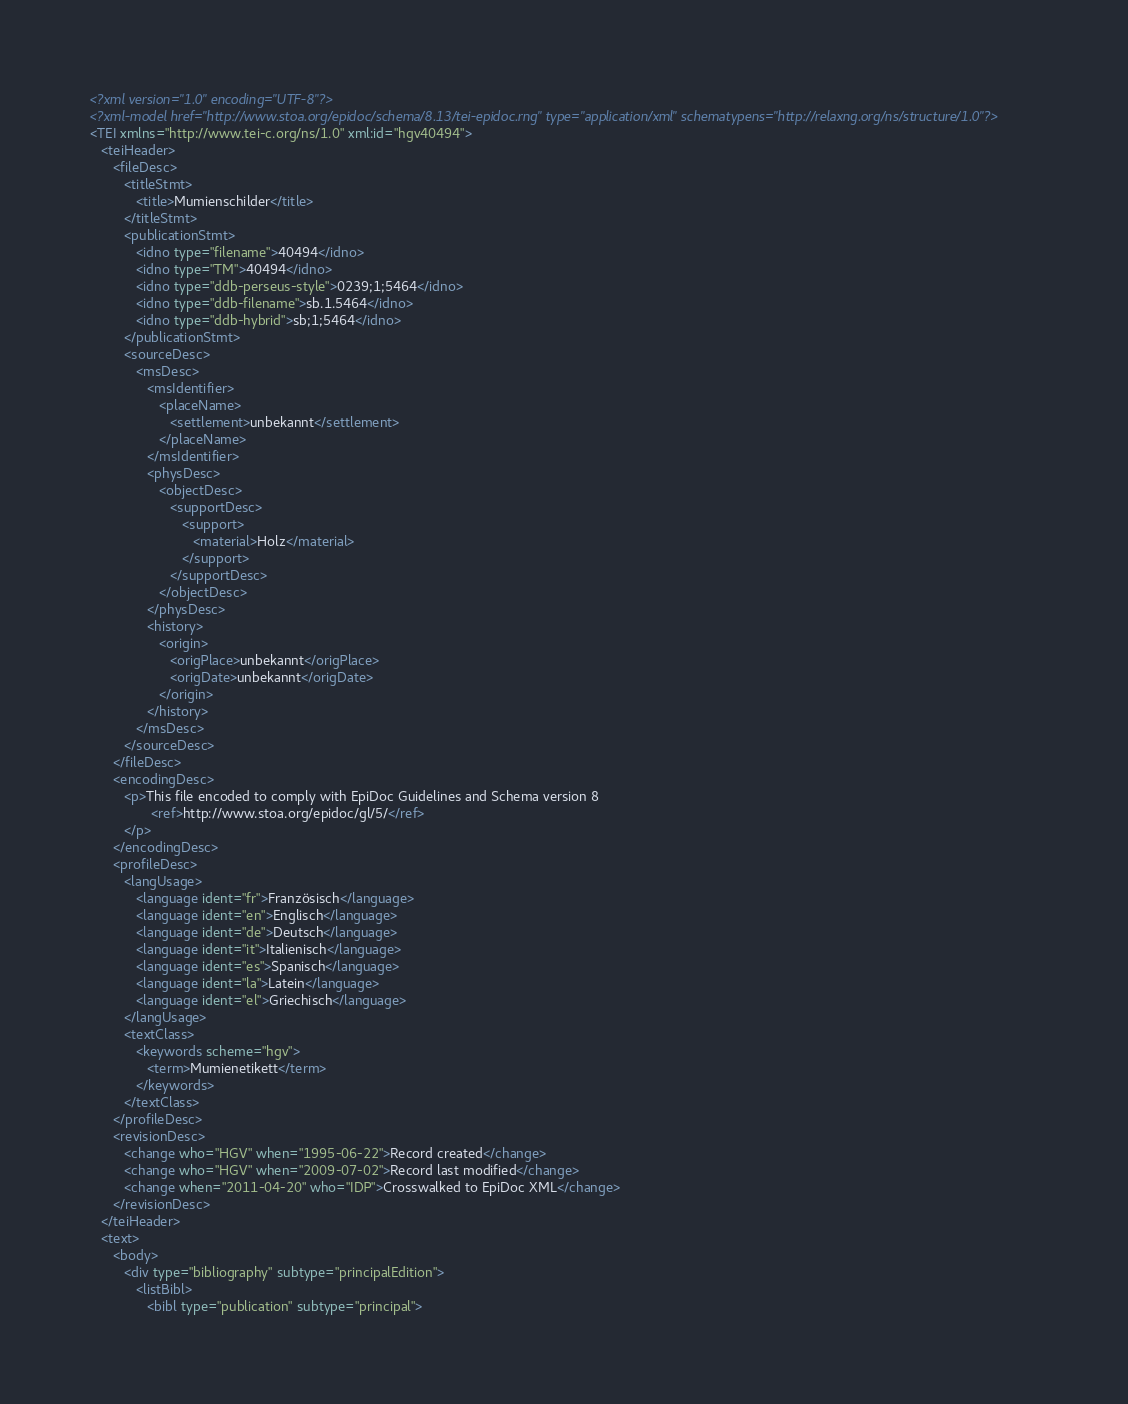<code> <loc_0><loc_0><loc_500><loc_500><_XML_><?xml version="1.0" encoding="UTF-8"?>
<?xml-model href="http://www.stoa.org/epidoc/schema/8.13/tei-epidoc.rng" type="application/xml" schematypens="http://relaxng.org/ns/structure/1.0"?>
<TEI xmlns="http://www.tei-c.org/ns/1.0" xml:id="hgv40494">
   <teiHeader>
      <fileDesc>
         <titleStmt>
            <title>Mumienschilder</title>
         </titleStmt>
         <publicationStmt>
            <idno type="filename">40494</idno>
            <idno type="TM">40494</idno>
            <idno type="ddb-perseus-style">0239;1;5464</idno>
            <idno type="ddb-filename">sb.1.5464</idno>
            <idno type="ddb-hybrid">sb;1;5464</idno>
         </publicationStmt>
         <sourceDesc>
            <msDesc>
               <msIdentifier>
                  <placeName>
                     <settlement>unbekannt</settlement>
                  </placeName>
               </msIdentifier>
               <physDesc>
                  <objectDesc>
                     <supportDesc>
                        <support>
                           <material>Holz</material>
                        </support>
                     </supportDesc>
                  </objectDesc>
               </physDesc>
               <history>
                  <origin>
                     <origPlace>unbekannt</origPlace>
                     <origDate>unbekannt</origDate>
                  </origin>
               </history>
            </msDesc>
         </sourceDesc>
      </fileDesc>
      <encodingDesc>
         <p>This file encoded to comply with EpiDoc Guidelines and Schema version 8
                <ref>http://www.stoa.org/epidoc/gl/5/</ref>
         </p>
      </encodingDesc>
      <profileDesc>
         <langUsage>
            <language ident="fr">Französisch</language>
            <language ident="en">Englisch</language>
            <language ident="de">Deutsch</language>
            <language ident="it">Italienisch</language>
            <language ident="es">Spanisch</language>
            <language ident="la">Latein</language>
            <language ident="el">Griechisch</language>
         </langUsage>
         <textClass>
            <keywords scheme="hgv">
               <term>Mumienetikett</term>
            </keywords>
         </textClass>
      </profileDesc>
      <revisionDesc>
         <change who="HGV" when="1995-06-22">Record created</change>
         <change who="HGV" when="2009-07-02">Record last modified</change>
         <change when="2011-04-20" who="IDP">Crosswalked to EpiDoc XML</change>
      </revisionDesc>
   </teiHeader>
   <text>
      <body>
         <div type="bibliography" subtype="principalEdition">
            <listBibl>
               <bibl type="publication" subtype="principal"></code> 